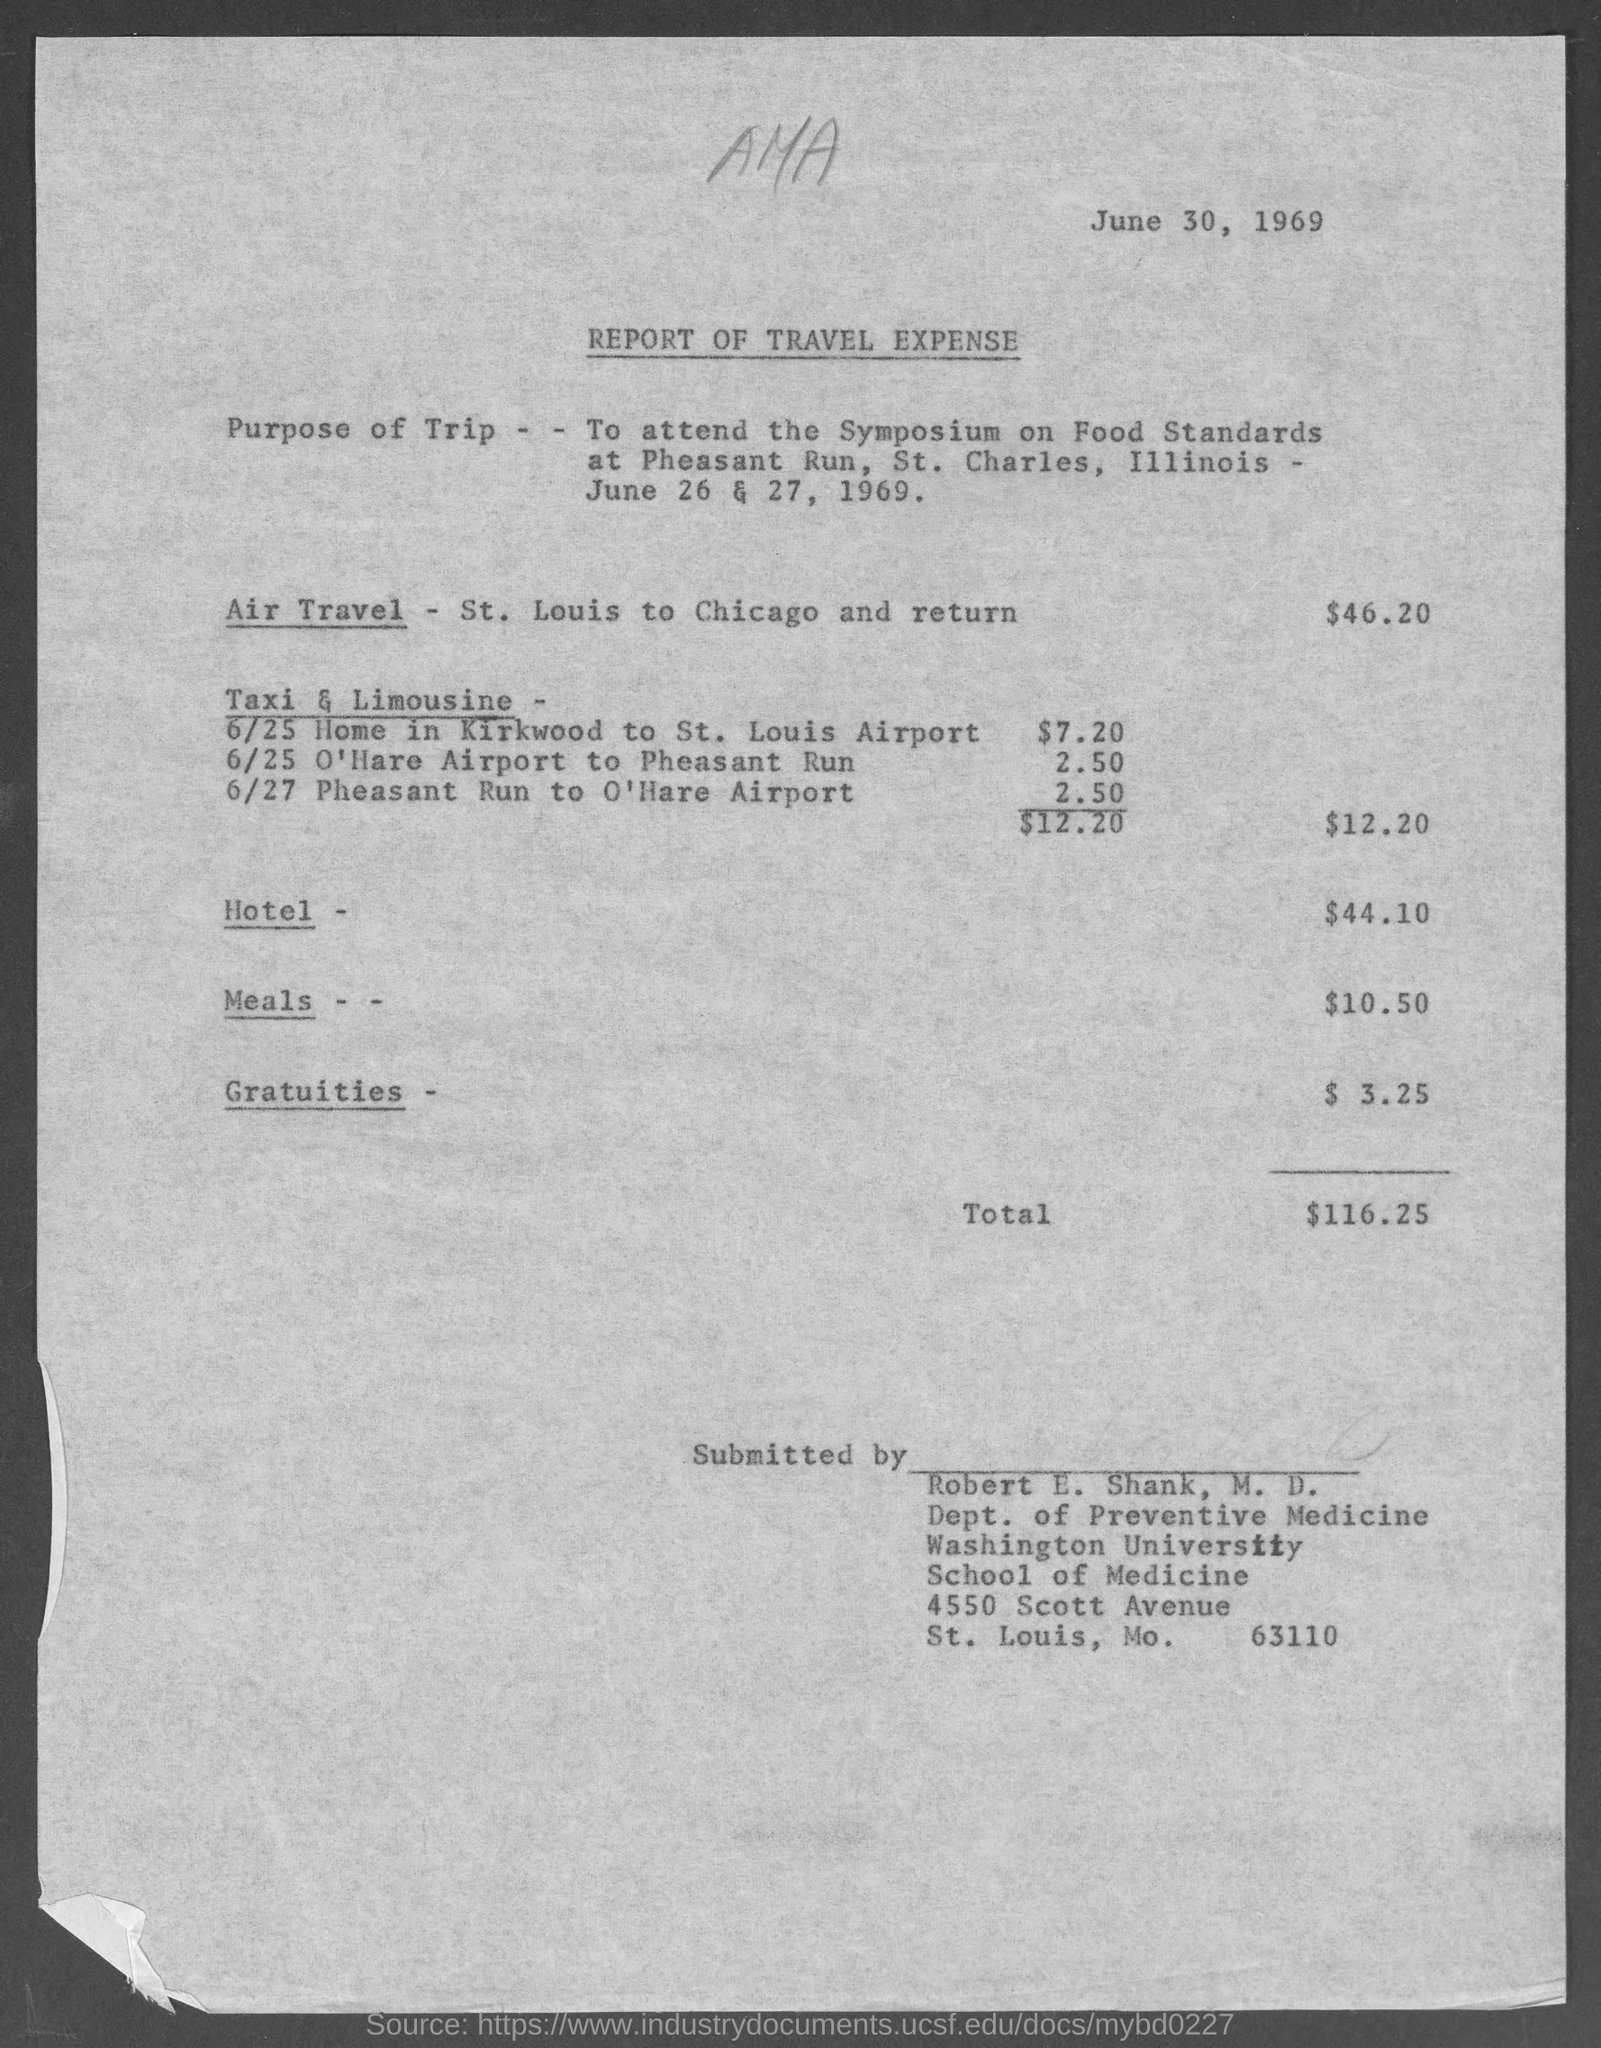Mention a couple of crucial points in this snapshot. Robert E. Shank, M.D., works in the Department of Preventive Medicine. The travel expense report was issued on June 30, 1969. The hotel expense mentioned in the report is 44.10. The air travel expense, as reported in the report, is $46.20. According to the report, the total travel expense is $116.25. 